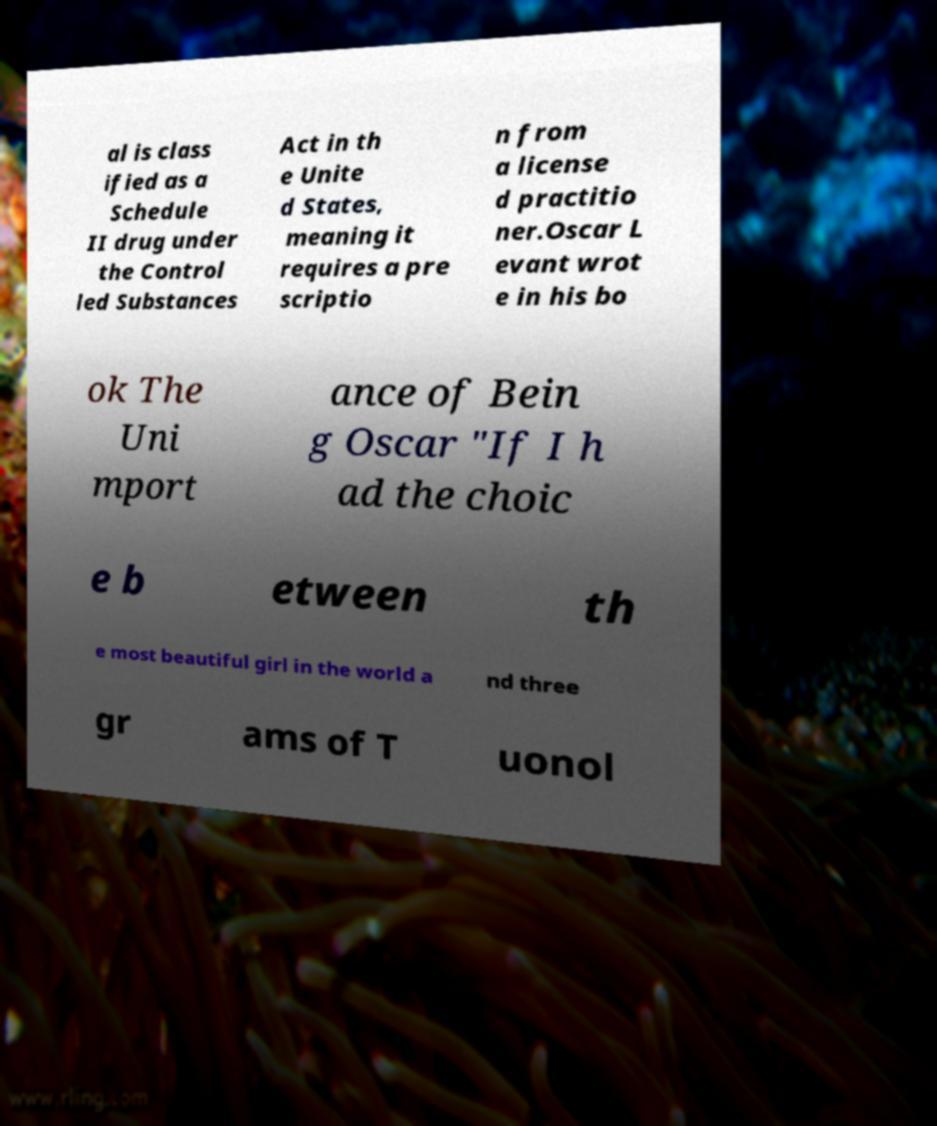Could you extract and type out the text from this image? al is class ified as a Schedule II drug under the Control led Substances Act in th e Unite d States, meaning it requires a pre scriptio n from a license d practitio ner.Oscar L evant wrot e in his bo ok The Uni mport ance of Bein g Oscar "If I h ad the choic e b etween th e most beautiful girl in the world a nd three gr ams of T uonol 